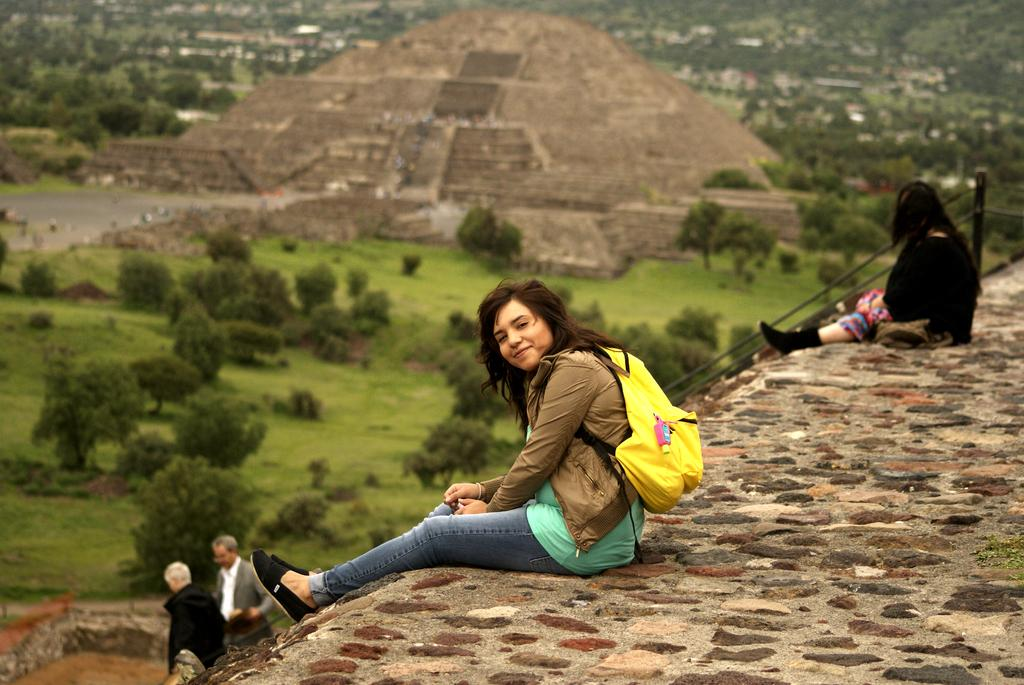How many people are sitting on the wall in the image? There are two women sitting on a wall in the image. What type of objects can be seen in the image? Metal poles are present in the image. How many men are in the image? There are two men in the image. What type of vegetation is visible in the image? There is a group of trees and grass in the image. What type of structure is visible in the image? There is an architecture and buildings in the image. What type of part can be seen on the carriage in the image? There is no carriage present in the image. What might surprise the women sitting on the wall in the image? It is impossible to determine what might surprise the women sitting on the wall in the image based solely on the provided facts. 